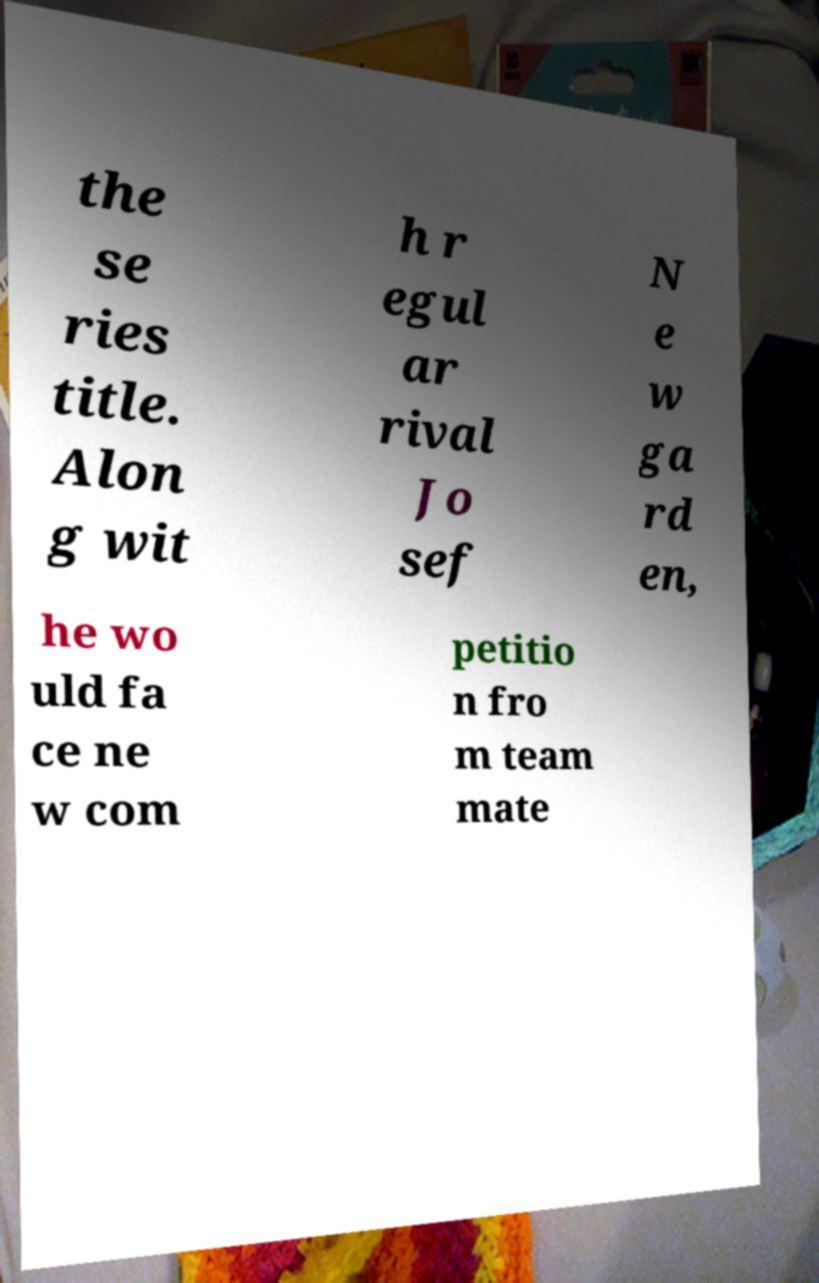Please read and relay the text visible in this image. What does it say? the se ries title. Alon g wit h r egul ar rival Jo sef N e w ga rd en, he wo uld fa ce ne w com petitio n fro m team mate 